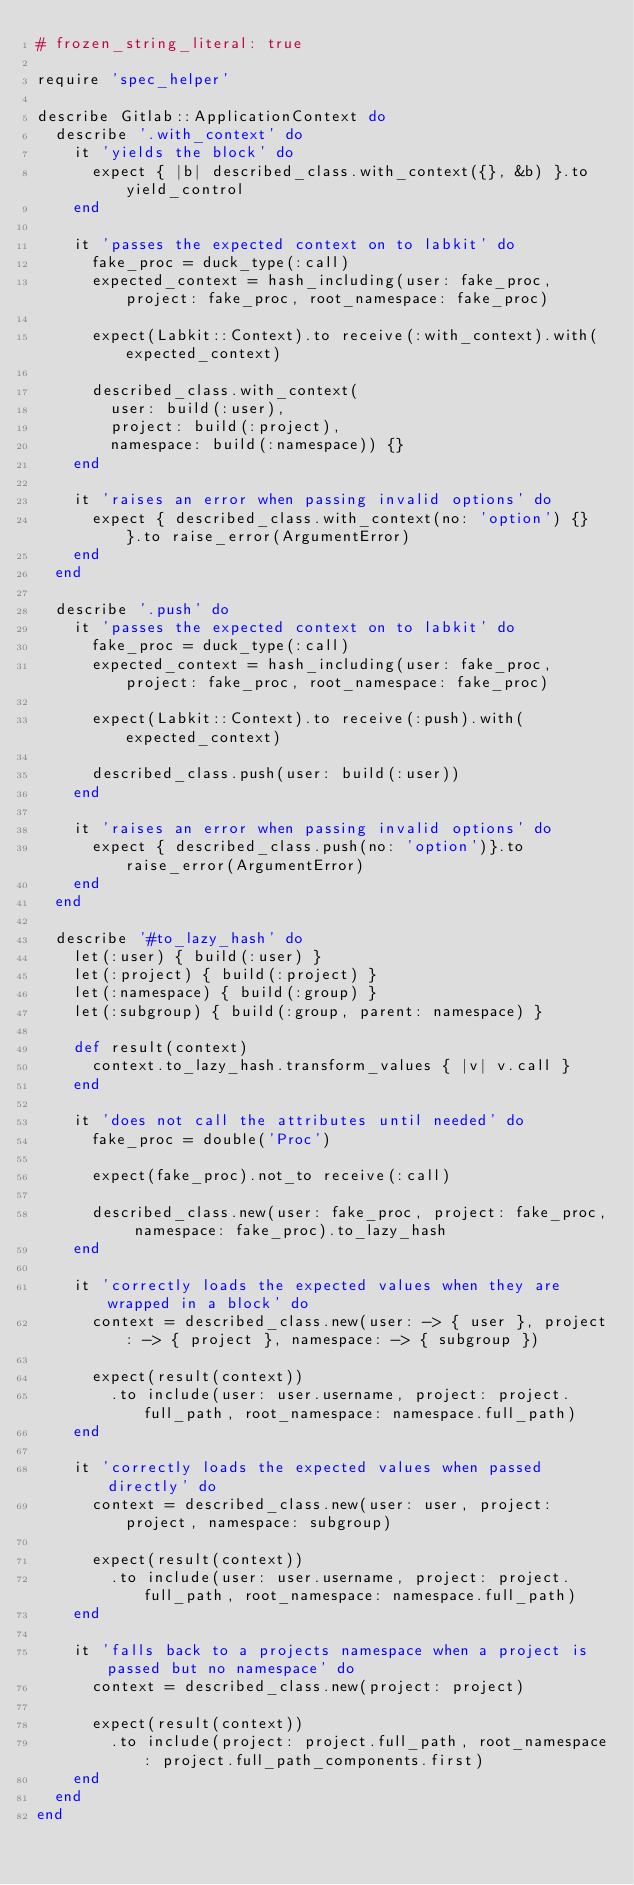Convert code to text. <code><loc_0><loc_0><loc_500><loc_500><_Ruby_># frozen_string_literal: true

require 'spec_helper'

describe Gitlab::ApplicationContext do
  describe '.with_context' do
    it 'yields the block' do
      expect { |b| described_class.with_context({}, &b) }.to yield_control
    end

    it 'passes the expected context on to labkit' do
      fake_proc = duck_type(:call)
      expected_context = hash_including(user: fake_proc, project: fake_proc, root_namespace: fake_proc)

      expect(Labkit::Context).to receive(:with_context).with(expected_context)

      described_class.with_context(
        user: build(:user),
        project: build(:project),
        namespace: build(:namespace)) {}
    end

    it 'raises an error when passing invalid options' do
      expect { described_class.with_context(no: 'option') {} }.to raise_error(ArgumentError)
    end
  end

  describe '.push' do
    it 'passes the expected context on to labkit' do
      fake_proc = duck_type(:call)
      expected_context = hash_including(user: fake_proc, project: fake_proc, root_namespace: fake_proc)

      expect(Labkit::Context).to receive(:push).with(expected_context)

      described_class.push(user: build(:user))
    end

    it 'raises an error when passing invalid options' do
      expect { described_class.push(no: 'option')}.to raise_error(ArgumentError)
    end
  end

  describe '#to_lazy_hash' do
    let(:user) { build(:user) }
    let(:project) { build(:project) }
    let(:namespace) { build(:group) }
    let(:subgroup) { build(:group, parent: namespace) }

    def result(context)
      context.to_lazy_hash.transform_values { |v| v.call }
    end

    it 'does not call the attributes until needed' do
      fake_proc = double('Proc')

      expect(fake_proc).not_to receive(:call)

      described_class.new(user: fake_proc, project: fake_proc, namespace: fake_proc).to_lazy_hash
    end

    it 'correctly loads the expected values when they are wrapped in a block' do
      context = described_class.new(user: -> { user }, project: -> { project }, namespace: -> { subgroup })

      expect(result(context))
        .to include(user: user.username, project: project.full_path, root_namespace: namespace.full_path)
    end

    it 'correctly loads the expected values when passed directly' do
      context = described_class.new(user: user, project: project, namespace: subgroup)

      expect(result(context))
        .to include(user: user.username, project: project.full_path, root_namespace: namespace.full_path)
    end

    it 'falls back to a projects namespace when a project is passed but no namespace' do
      context = described_class.new(project: project)

      expect(result(context))
        .to include(project: project.full_path, root_namespace: project.full_path_components.first)
    end
  end
end
</code> 